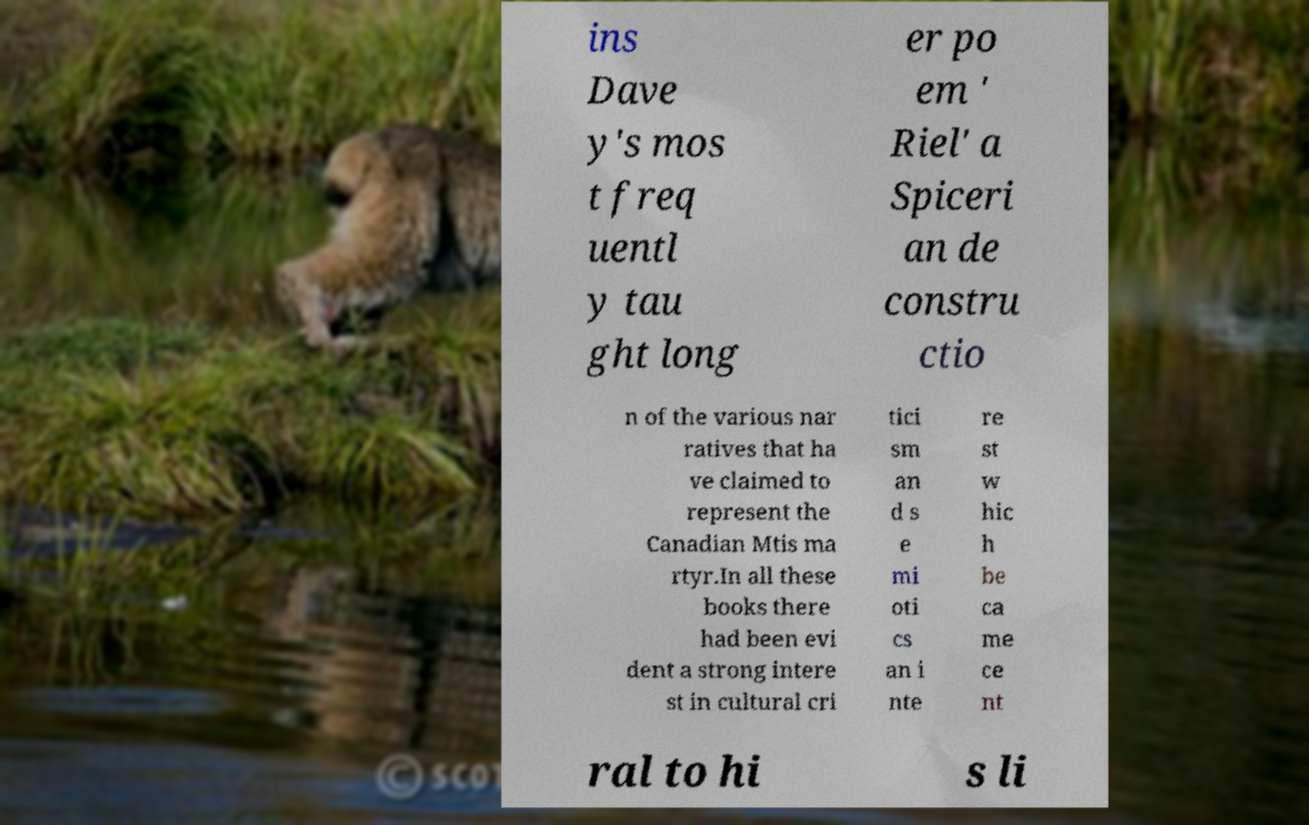Could you extract and type out the text from this image? ins Dave y's mos t freq uentl y tau ght long er po em ' Riel' a Spiceri an de constru ctio n of the various nar ratives that ha ve claimed to represent the Canadian Mtis ma rtyr.In all these books there had been evi dent a strong intere st in cultural cri tici sm an d s e mi oti cs an i nte re st w hic h be ca me ce nt ral to hi s li 